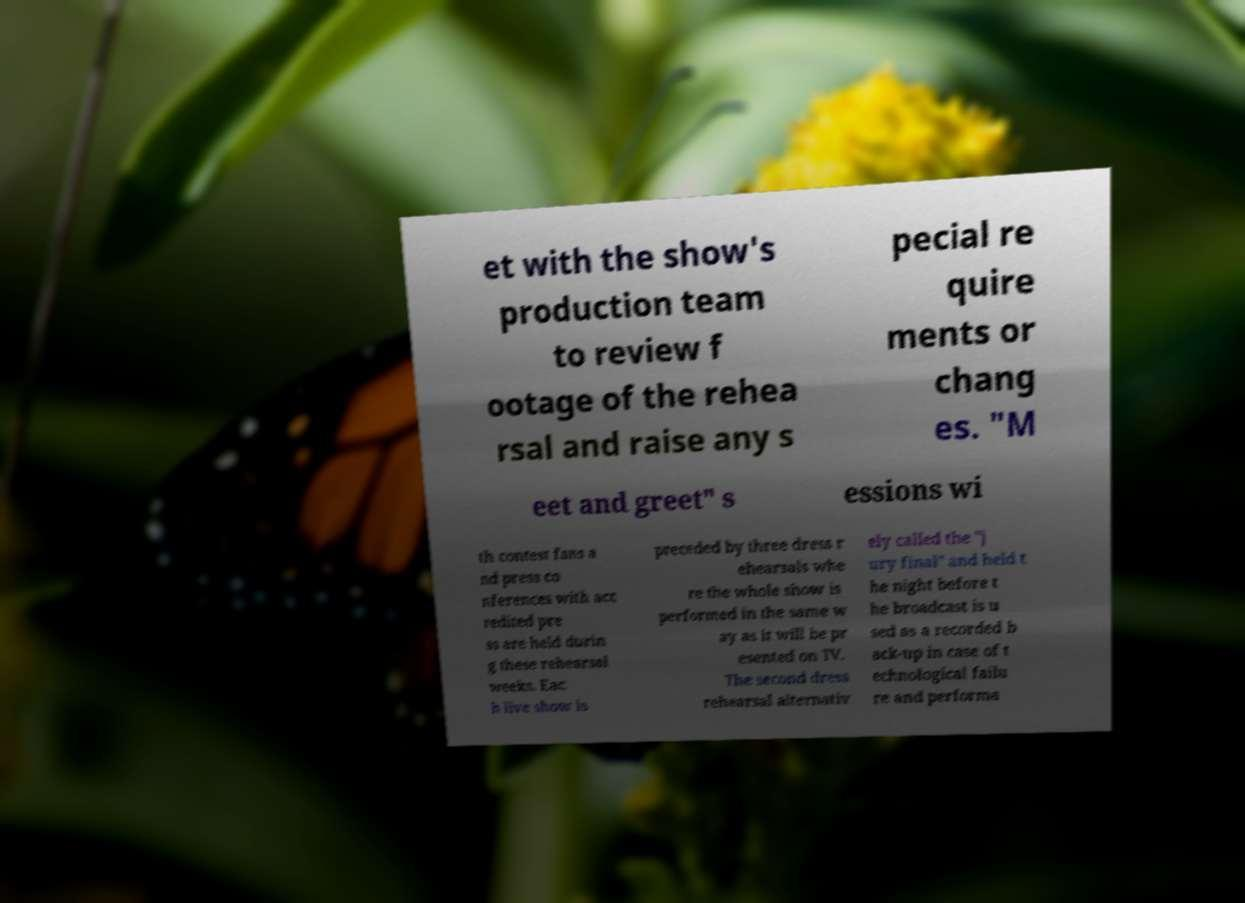Could you extract and type out the text from this image? et with the show's production team to review f ootage of the rehea rsal and raise any s pecial re quire ments or chang es. "M eet and greet" s essions wi th contest fans a nd press co nferences with acc redited pre ss are held durin g these rehearsal weeks. Eac h live show is preceded by three dress r ehearsals whe re the whole show is performed in the same w ay as it will be pr esented on TV. The second dress rehearsal alternativ ely called the "j ury final" and held t he night before t he broadcast is u sed as a recorded b ack-up in case of t echnological failu re and performa 